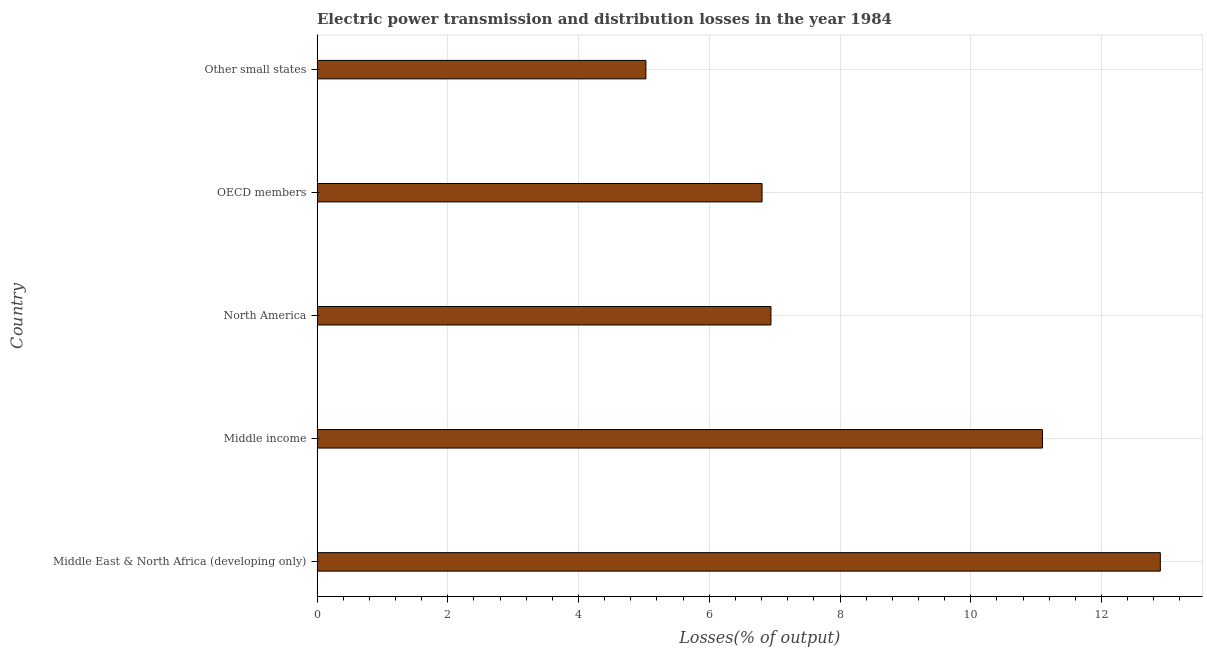What is the title of the graph?
Provide a succinct answer. Electric power transmission and distribution losses in the year 1984. What is the label or title of the X-axis?
Your response must be concise. Losses(% of output). What is the electric power transmission and distribution losses in Middle East & North Africa (developing only)?
Offer a very short reply. 12.9. Across all countries, what is the maximum electric power transmission and distribution losses?
Provide a short and direct response. 12.9. Across all countries, what is the minimum electric power transmission and distribution losses?
Provide a short and direct response. 5.03. In which country was the electric power transmission and distribution losses maximum?
Provide a succinct answer. Middle East & North Africa (developing only). In which country was the electric power transmission and distribution losses minimum?
Offer a very short reply. Other small states. What is the sum of the electric power transmission and distribution losses?
Provide a short and direct response. 42.78. What is the difference between the electric power transmission and distribution losses in Middle East & North Africa (developing only) and OECD members?
Your response must be concise. 6.09. What is the average electric power transmission and distribution losses per country?
Keep it short and to the point. 8.56. What is the median electric power transmission and distribution losses?
Give a very brief answer. 6.94. In how many countries, is the electric power transmission and distribution losses greater than 1.2 %?
Ensure brevity in your answer.  5. What is the ratio of the electric power transmission and distribution losses in North America to that in Other small states?
Keep it short and to the point. 1.38. Is the electric power transmission and distribution losses in Middle income less than that in Other small states?
Provide a succinct answer. No. What is the difference between the highest and the second highest electric power transmission and distribution losses?
Ensure brevity in your answer.  1.8. Is the sum of the electric power transmission and distribution losses in Middle income and Other small states greater than the maximum electric power transmission and distribution losses across all countries?
Provide a short and direct response. Yes. What is the difference between the highest and the lowest electric power transmission and distribution losses?
Offer a very short reply. 7.87. In how many countries, is the electric power transmission and distribution losses greater than the average electric power transmission and distribution losses taken over all countries?
Make the answer very short. 2. How many bars are there?
Offer a terse response. 5. Are all the bars in the graph horizontal?
Your answer should be very brief. Yes. How many countries are there in the graph?
Offer a very short reply. 5. Are the values on the major ticks of X-axis written in scientific E-notation?
Make the answer very short. No. What is the Losses(% of output) of Middle East & North Africa (developing only)?
Offer a very short reply. 12.9. What is the Losses(% of output) in Middle income?
Provide a short and direct response. 11.1. What is the Losses(% of output) in North America?
Provide a short and direct response. 6.94. What is the Losses(% of output) of OECD members?
Your response must be concise. 6.81. What is the Losses(% of output) in Other small states?
Offer a terse response. 5.03. What is the difference between the Losses(% of output) in Middle East & North Africa (developing only) and Middle income?
Keep it short and to the point. 1.8. What is the difference between the Losses(% of output) in Middle East & North Africa (developing only) and North America?
Provide a short and direct response. 5.96. What is the difference between the Losses(% of output) in Middle East & North Africa (developing only) and OECD members?
Your response must be concise. 6.09. What is the difference between the Losses(% of output) in Middle East & North Africa (developing only) and Other small states?
Offer a terse response. 7.87. What is the difference between the Losses(% of output) in Middle income and North America?
Offer a very short reply. 4.15. What is the difference between the Losses(% of output) in Middle income and OECD members?
Provide a short and direct response. 4.29. What is the difference between the Losses(% of output) in Middle income and Other small states?
Keep it short and to the point. 6.07. What is the difference between the Losses(% of output) in North America and OECD members?
Offer a very short reply. 0.14. What is the difference between the Losses(% of output) in North America and Other small states?
Make the answer very short. 1.91. What is the difference between the Losses(% of output) in OECD members and Other small states?
Provide a short and direct response. 1.78. What is the ratio of the Losses(% of output) in Middle East & North Africa (developing only) to that in Middle income?
Offer a terse response. 1.16. What is the ratio of the Losses(% of output) in Middle East & North Africa (developing only) to that in North America?
Ensure brevity in your answer.  1.86. What is the ratio of the Losses(% of output) in Middle East & North Africa (developing only) to that in OECD members?
Give a very brief answer. 1.9. What is the ratio of the Losses(% of output) in Middle East & North Africa (developing only) to that in Other small states?
Provide a short and direct response. 2.56. What is the ratio of the Losses(% of output) in Middle income to that in North America?
Provide a succinct answer. 1.6. What is the ratio of the Losses(% of output) in Middle income to that in OECD members?
Your answer should be compact. 1.63. What is the ratio of the Losses(% of output) in Middle income to that in Other small states?
Offer a very short reply. 2.21. What is the ratio of the Losses(% of output) in North America to that in OECD members?
Provide a short and direct response. 1.02. What is the ratio of the Losses(% of output) in North America to that in Other small states?
Ensure brevity in your answer.  1.38. What is the ratio of the Losses(% of output) in OECD members to that in Other small states?
Ensure brevity in your answer.  1.35. 